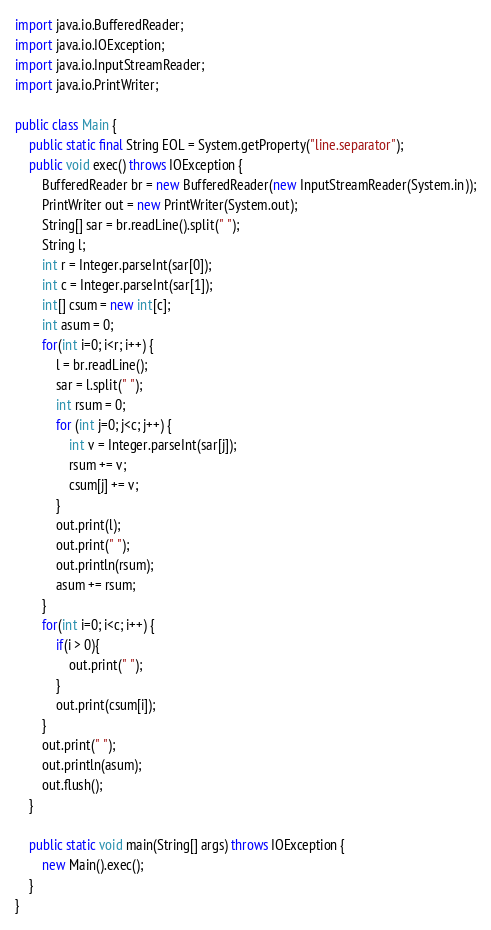<code> <loc_0><loc_0><loc_500><loc_500><_Java_>import java.io.BufferedReader;
import java.io.IOException;
import java.io.InputStreamReader;
import java.io.PrintWriter;

public class Main {
	public static final String EOL = System.getProperty("line.separator");
    public void exec() throws IOException {
    	BufferedReader br = new BufferedReader(new InputStreamReader(System.in));
    	PrintWriter out = new PrintWriter(System.out);
    	String[] sar = br.readLine().split(" ");
    	String l;
    	int r = Integer.parseInt(sar[0]);
    	int c = Integer.parseInt(sar[1]);
    	int[] csum = new int[c];
    	int asum = 0;
    	for(int i=0; i<r; i++) {
    		l = br.readLine();
    		sar = l.split(" ");
    		int rsum = 0;
    		for (int j=0; j<c; j++) {
    			int v = Integer.parseInt(sar[j]);
    			rsum += v;
    			csum[j] += v;
    		}
    		out.print(l);
    		out.print(" ");
    		out.println(rsum);
    		asum += rsum;
    	}
        for(int i=0; i<c; i++) {
        	if(i > 0){
        		out.print(" ");
        	}
        	out.print(csum[i]);
        }
        out.print(" ");
        out.println(asum);
        out.flush();
    }
 
    public static void main(String[] args) throws IOException {
    	new Main().exec();
    }
}</code> 